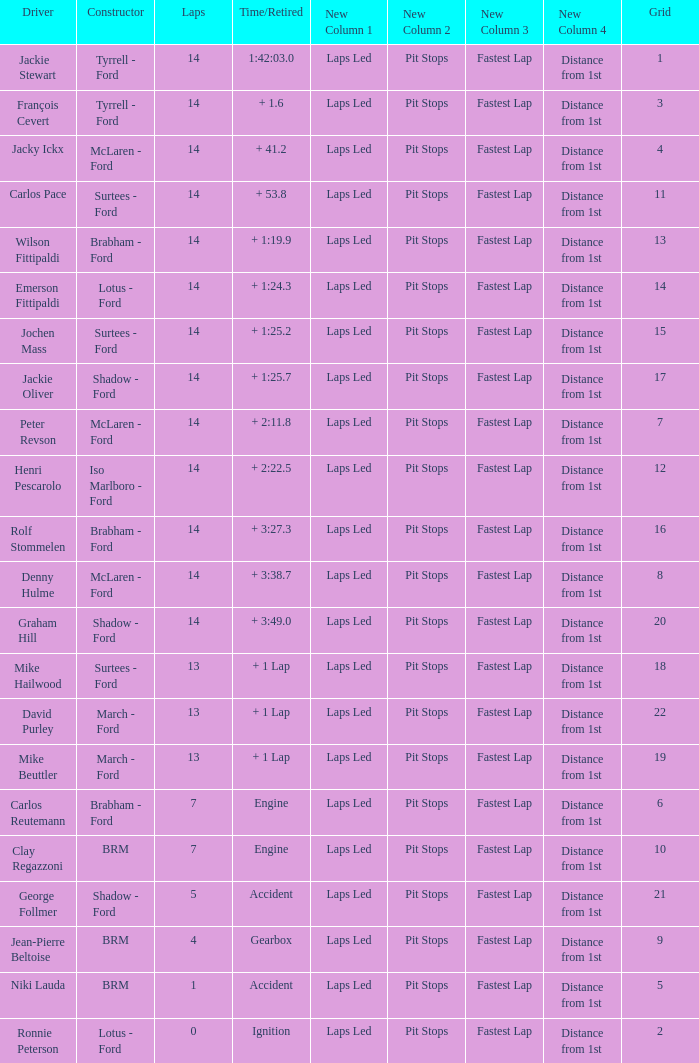What is the low lap total for henri pescarolo with a grad larger than 6? 14.0. 